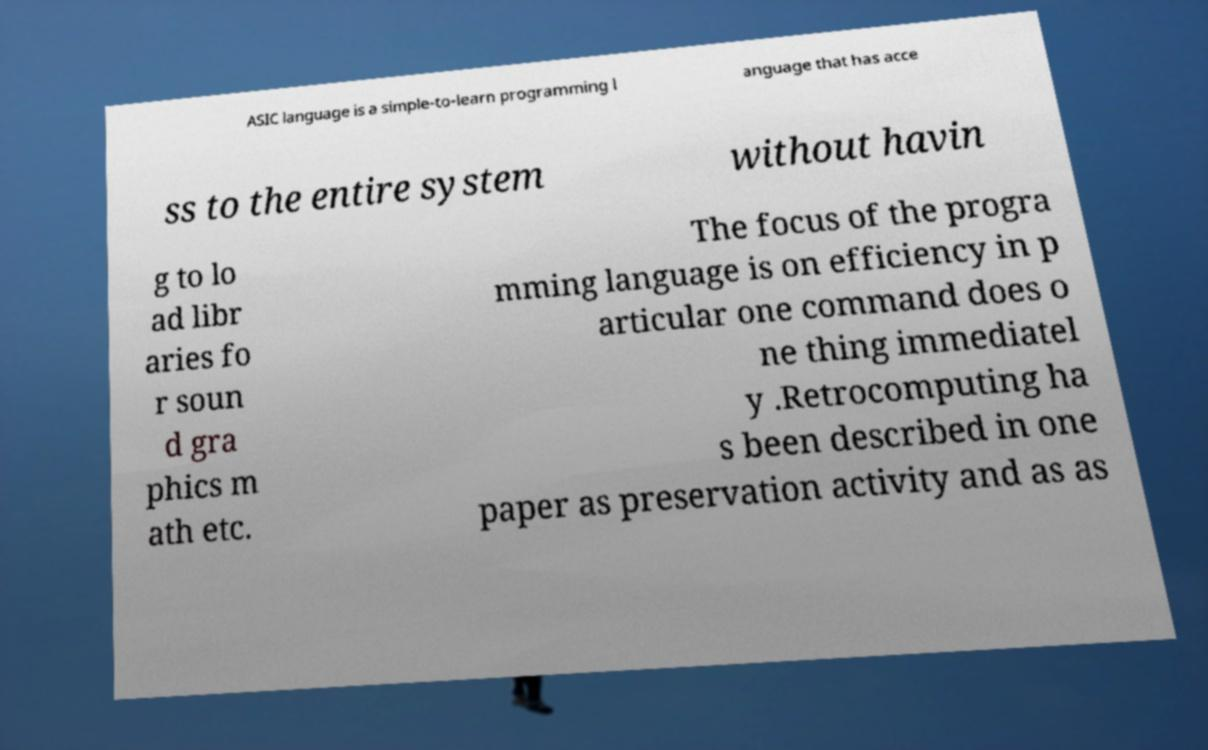Can you read and provide the text displayed in the image?This photo seems to have some interesting text. Can you extract and type it out for me? ASIC language is a simple-to-learn programming l anguage that has acce ss to the entire system without havin g to lo ad libr aries fo r soun d gra phics m ath etc. The focus of the progra mming language is on efficiency in p articular one command does o ne thing immediatel y .Retrocomputing ha s been described in one paper as preservation activity and as as 